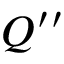Convert formula to latex. <formula><loc_0><loc_0><loc_500><loc_500>Q ^ { \prime \prime }</formula> 